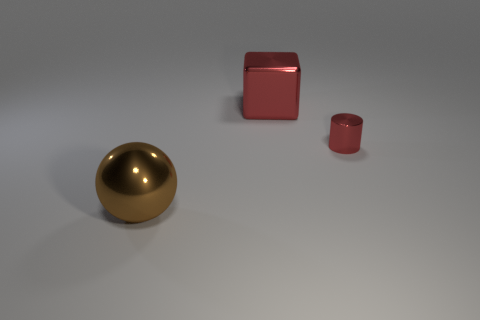Add 3 brown shiny spheres. How many objects exist? 6 Subtract all spheres. How many objects are left? 2 Subtract all brown cubes. How many blue balls are left? 0 Subtract all large red things. Subtract all small metal things. How many objects are left? 1 Add 2 tiny objects. How many tiny objects are left? 3 Add 2 red metal cylinders. How many red metal cylinders exist? 3 Subtract 0 purple blocks. How many objects are left? 3 Subtract all brown blocks. Subtract all cyan cylinders. How many blocks are left? 1 